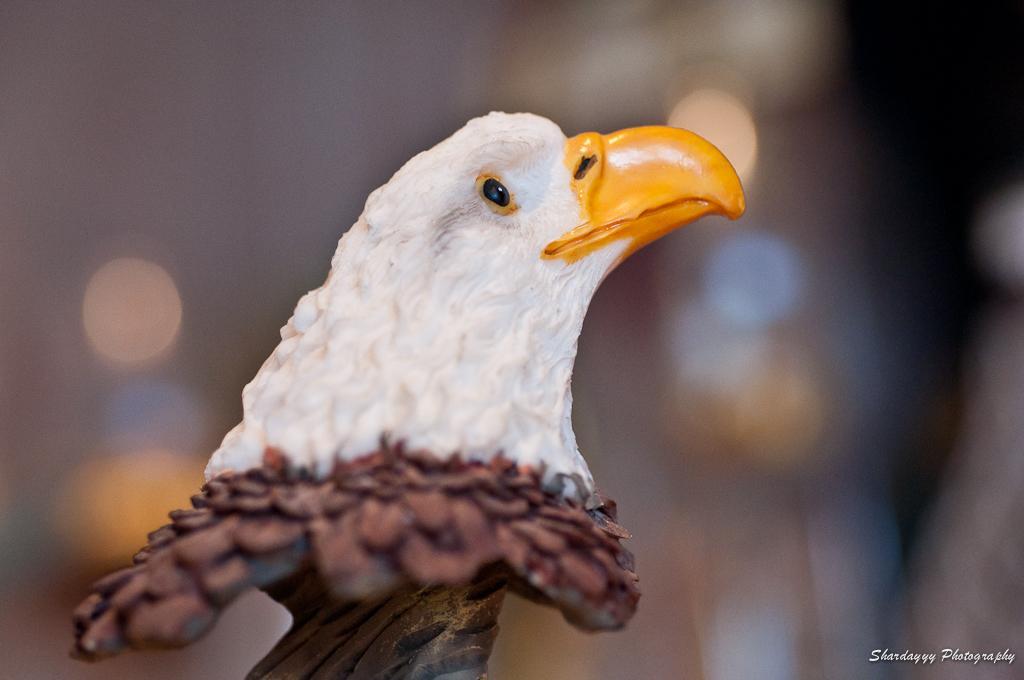Can you describe this image briefly? Here in this picture we can see a statue of an eagle present over there. 